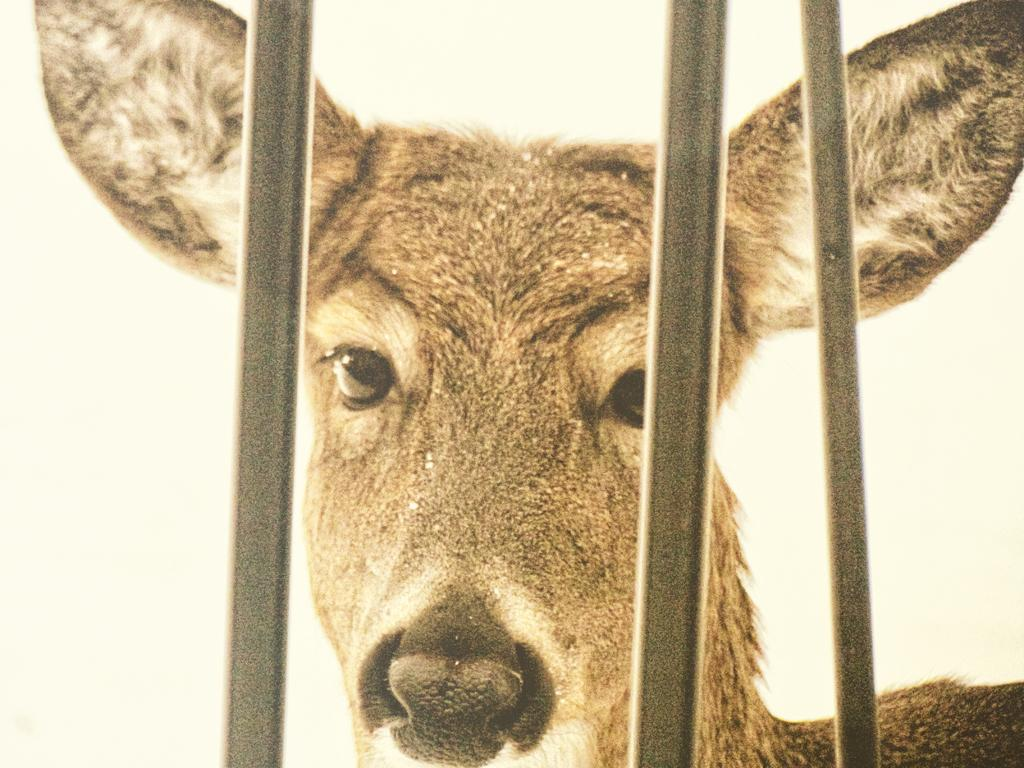What animal is present in the image? There is a deer in the image. What objects can be seen in the image besides the deer? There are rods in the image. What is the color of the background in the image? The background of the image is white. How many pizzas are being held by the deer in the image? There are no pizzas present in the image; it features a deer and rods against a white background. What expertise does the deer have in the image? The deer is an animal and does not possess any specific expertise in the image. 